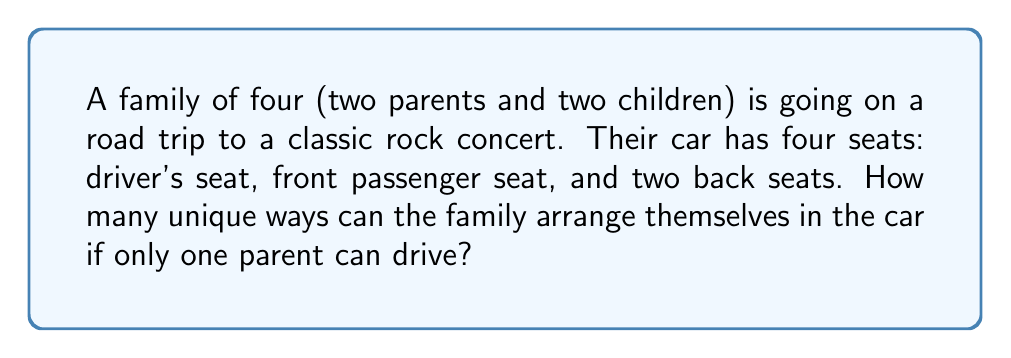Provide a solution to this math problem. Let's approach this step-by-step:

1) First, we need to consider the driver's seat. Only one parent can drive, so there are 2 choices for the driver's seat.

2) After the driver is seated, we have 3 people left to arrange in the remaining 3 seats.

3) This becomes a permutation problem. We can calculate the number of ways to arrange 3 people in 3 seats using the formula:

   $$P(3,3) = 3!$$

4) Where 3! (3 factorial) is calculated as:

   $$3! = 3 \times 2 \times 1 = 6$$

5) Now, we can apply the multiplication principle. The total number of arrangements is the product of:
   - The number of choices for the driver (2)
   - The number of ways to arrange the remaining 3 people (6)

6) Therefore, the total number of unique arrangements is:

   $$2 \times 6 = 12$$
Answer: 12 